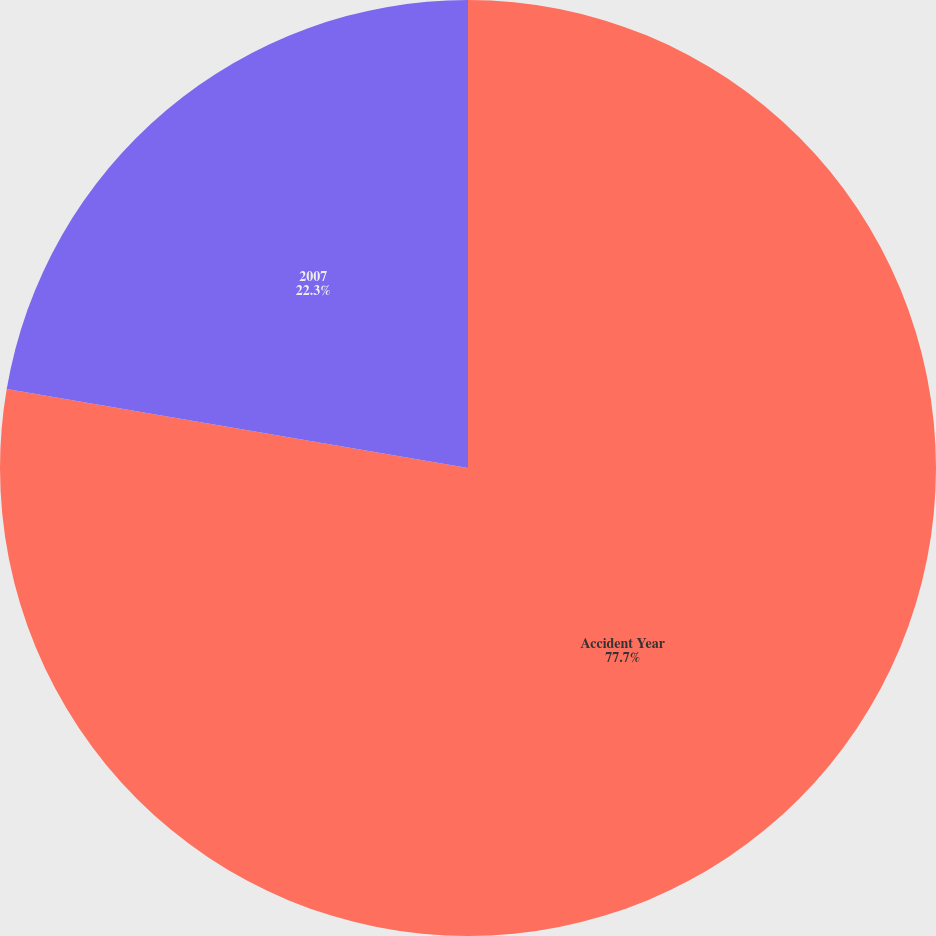Convert chart. <chart><loc_0><loc_0><loc_500><loc_500><pie_chart><fcel>Accident Year<fcel>2007<nl><fcel>77.7%<fcel>22.3%<nl></chart> 